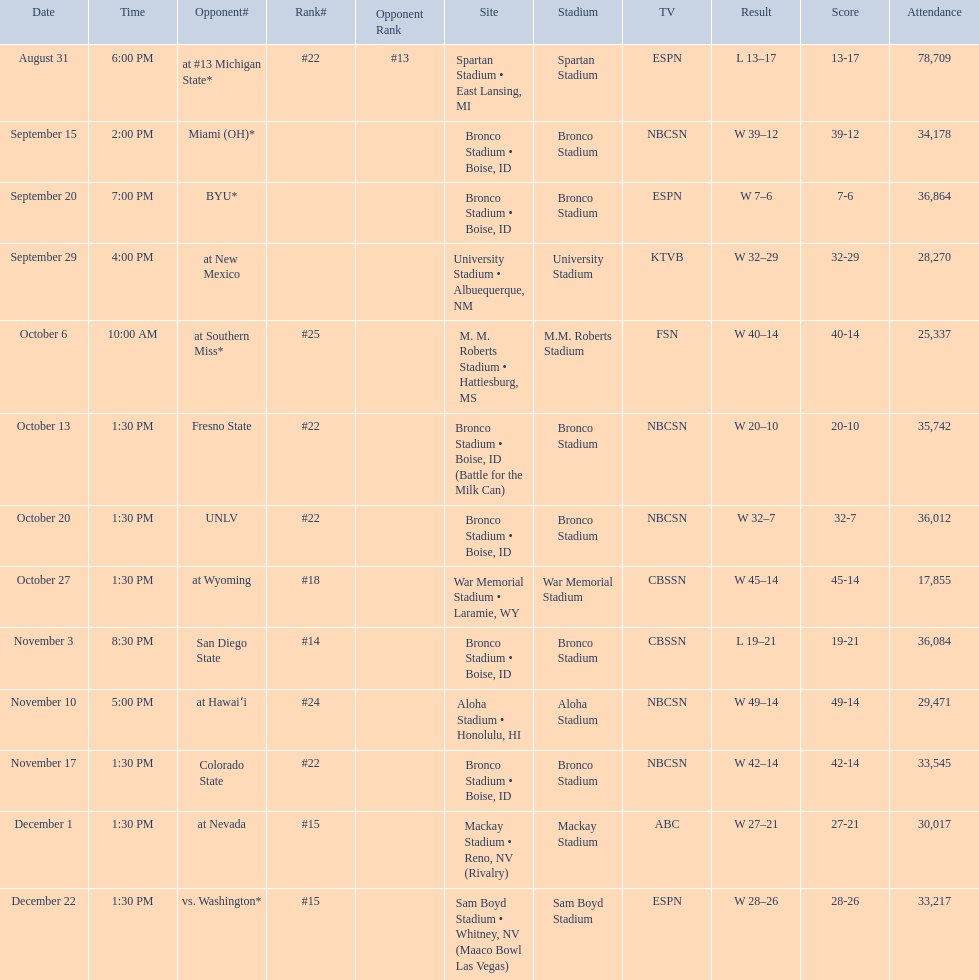Who were all of the opponents? At #13 michigan state*, miami (oh)*, byu*, at new mexico, at southern miss*, fresno state, unlv, at wyoming, san diego state, at hawaiʻi, colorado state, at nevada, vs. washington*. Who did they face on november 3rd? San Diego State. What rank were they on november 3rd? #14. 